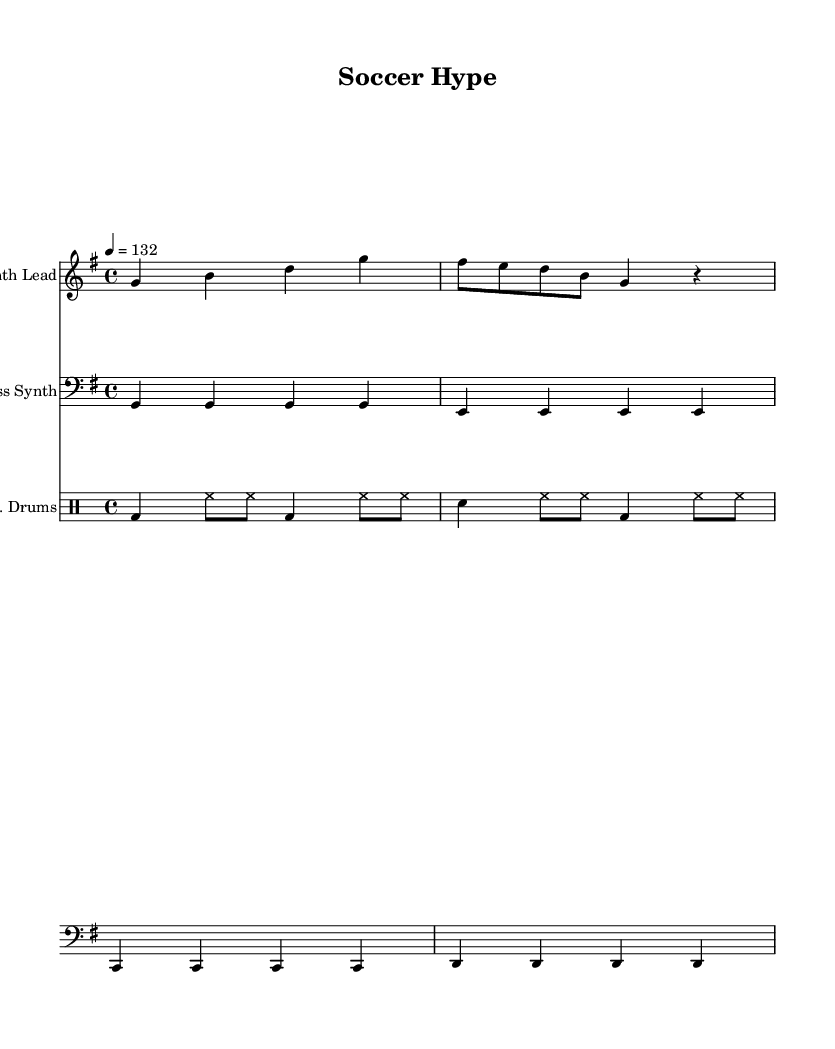What is the key signature of this music? The key signature is G major, which has one sharp (F#). You can determine this by looking at the beginning of the sheet music, where the key is indicated.
Answer: G major What is the time signature of this piece? The time signature is 4/4, which can be found at the beginning of the sheet music. This means there are four beats in every measure.
Answer: 4/4 What is the tempo marking for this composition? The tempo marking is quarter note = 132. This is indicated at the top of the sheet music and tells how fast the music should be played.
Answer: 132 How many measures are in the melody? There are four measures in the melody, which can be counted by looking at the notation in the staff labeled "Synth Lead." Each vertical line represents a measure.
Answer: 4 How many different instruments are used in this sheet music? Three different instruments are present: Synth Lead, Bass Synth, and E. Drums. You can find this information in the staff headers at the beginning of each section.
Answer: 3 Which rhythm predominates in the drum part? The predominant rhythm is a combination of bass drum and hi-hat on eighth notes and quarter notes. This can be concluded by analyzing the patterns in the "E. Drums" staff, where the drum notations show repeated beats.
Answer: Bass drum and hi-hat What is the main purpose of this music composition? The main purpose is to hype players before a soccer game, as it is energetic electronic dance music designed for pre-game warm-ups. This is inferred from the title "Soccer Hype" and genre characteristics.
Answer: Pre-game warm-ups 